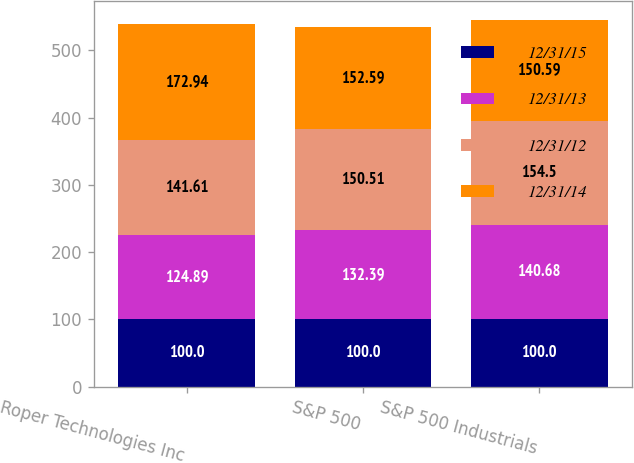Convert chart. <chart><loc_0><loc_0><loc_500><loc_500><stacked_bar_chart><ecel><fcel>Roper Technologies Inc<fcel>S&P 500<fcel>S&P 500 Industrials<nl><fcel>12/31/15<fcel>100<fcel>100<fcel>100<nl><fcel>12/31/13<fcel>124.89<fcel>132.39<fcel>140.68<nl><fcel>12/31/12<fcel>141.61<fcel>150.51<fcel>154.5<nl><fcel>12/31/14<fcel>172.94<fcel>152.59<fcel>150.59<nl></chart> 